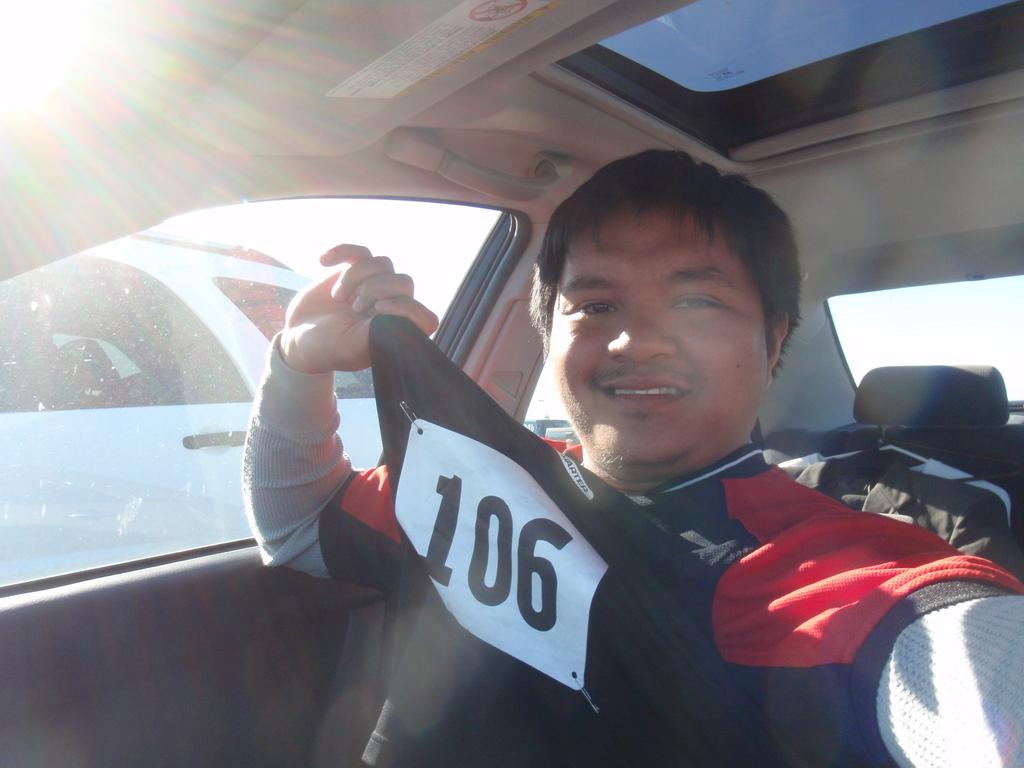Who is present in the image? There is a man in the image. What is the man wearing? The man is wearing a t-shirt. What is the man doing in the image? The man is sitting in a car. What is the man's facial expression in the image? The man is smiling. What type of straw is the man using to blow bubbles in the image? There is no straw or bubbles present in the image; the man is simply sitting in a car and smiling. 